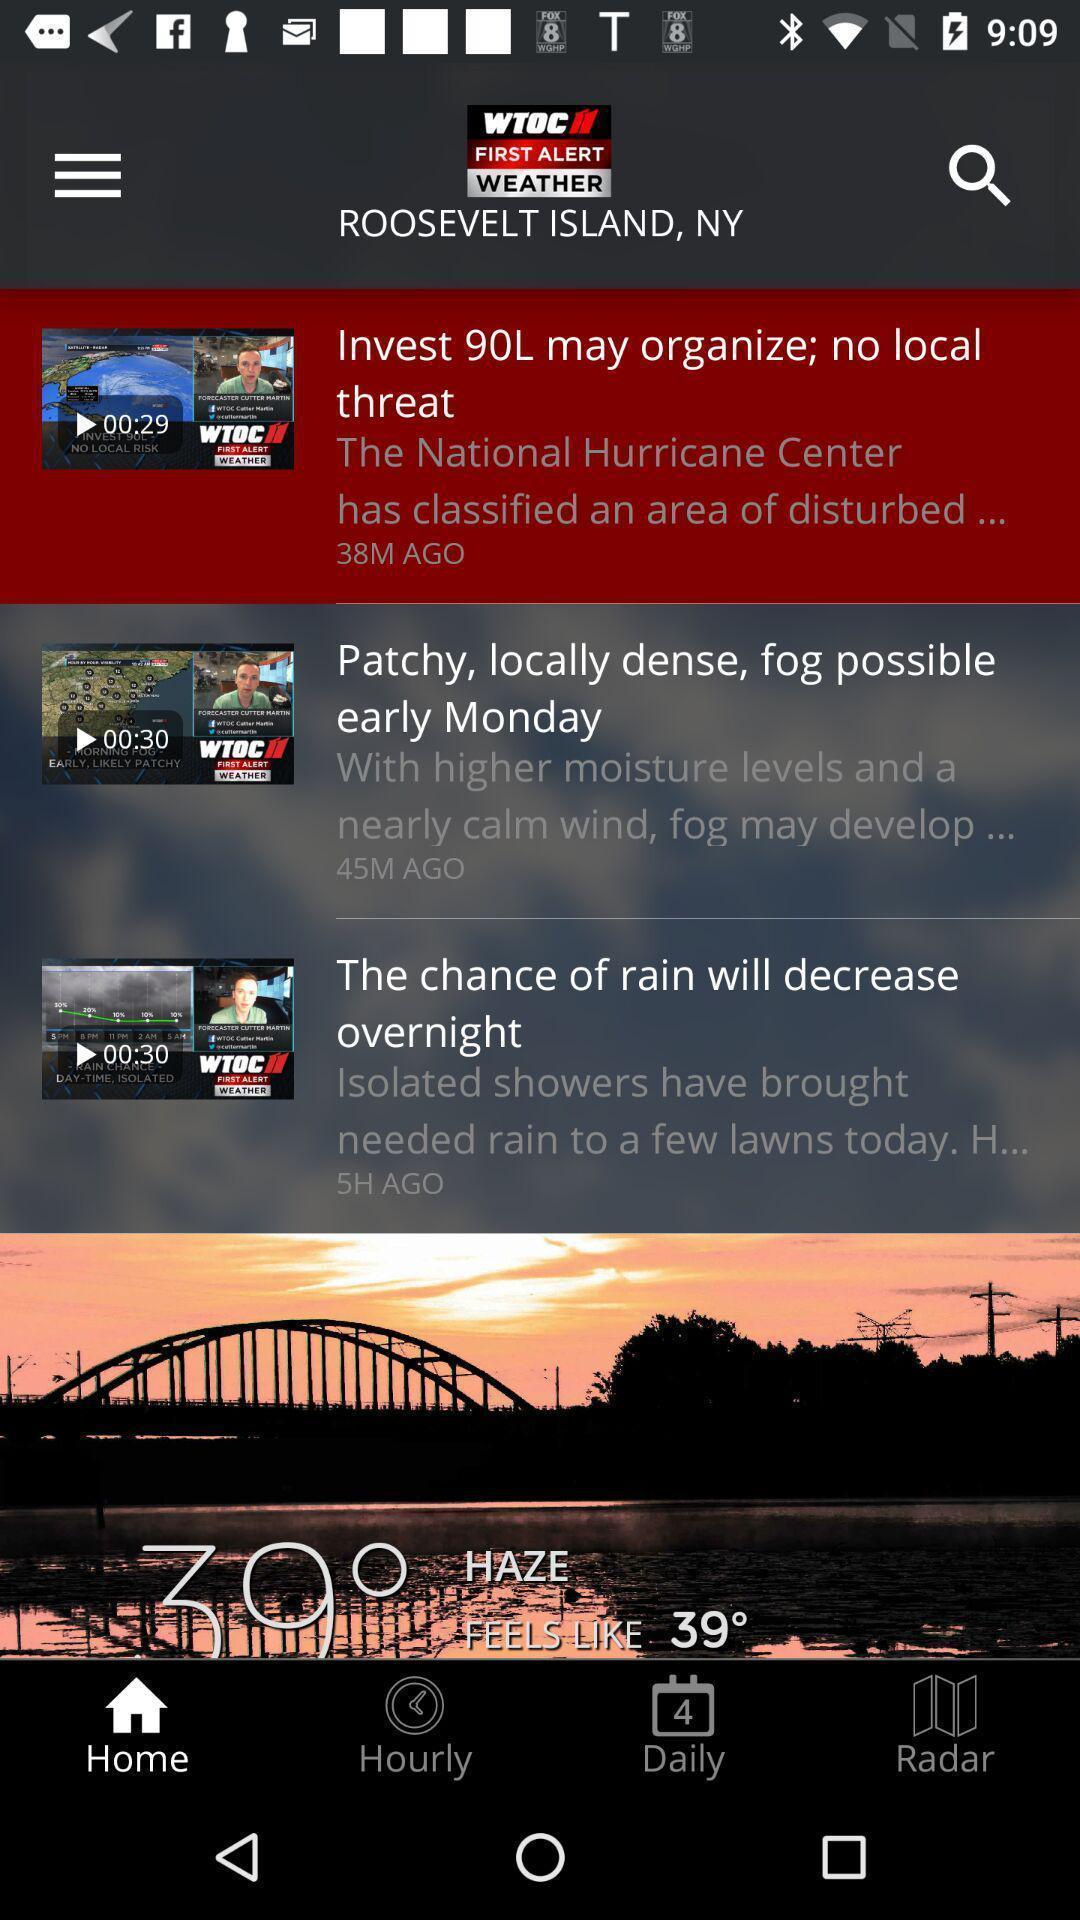What details can you identify in this image? Screen displaying a list of videos in a weather application. 